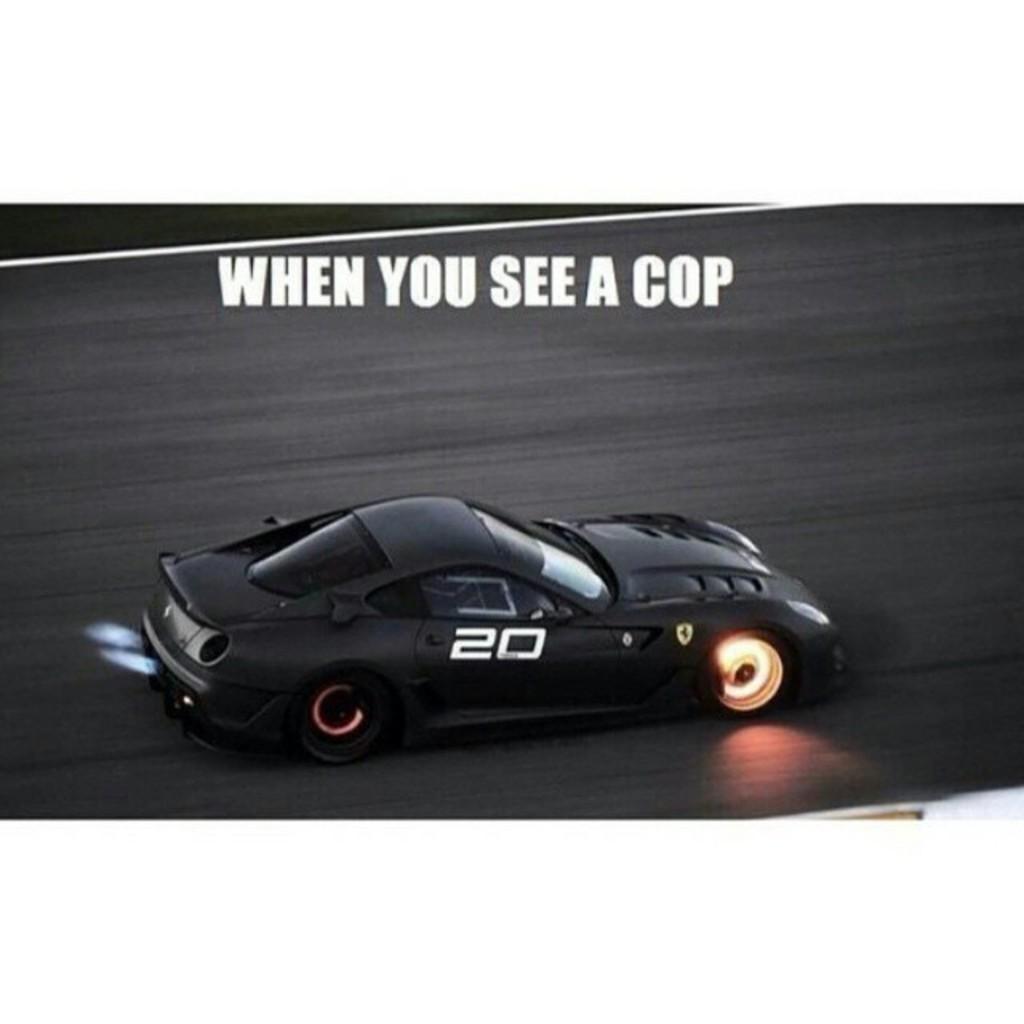Could you give a brief overview of what you see in this image? In the image there is a poster. On the poster there is a car on the road. And also there is text on the poster. 